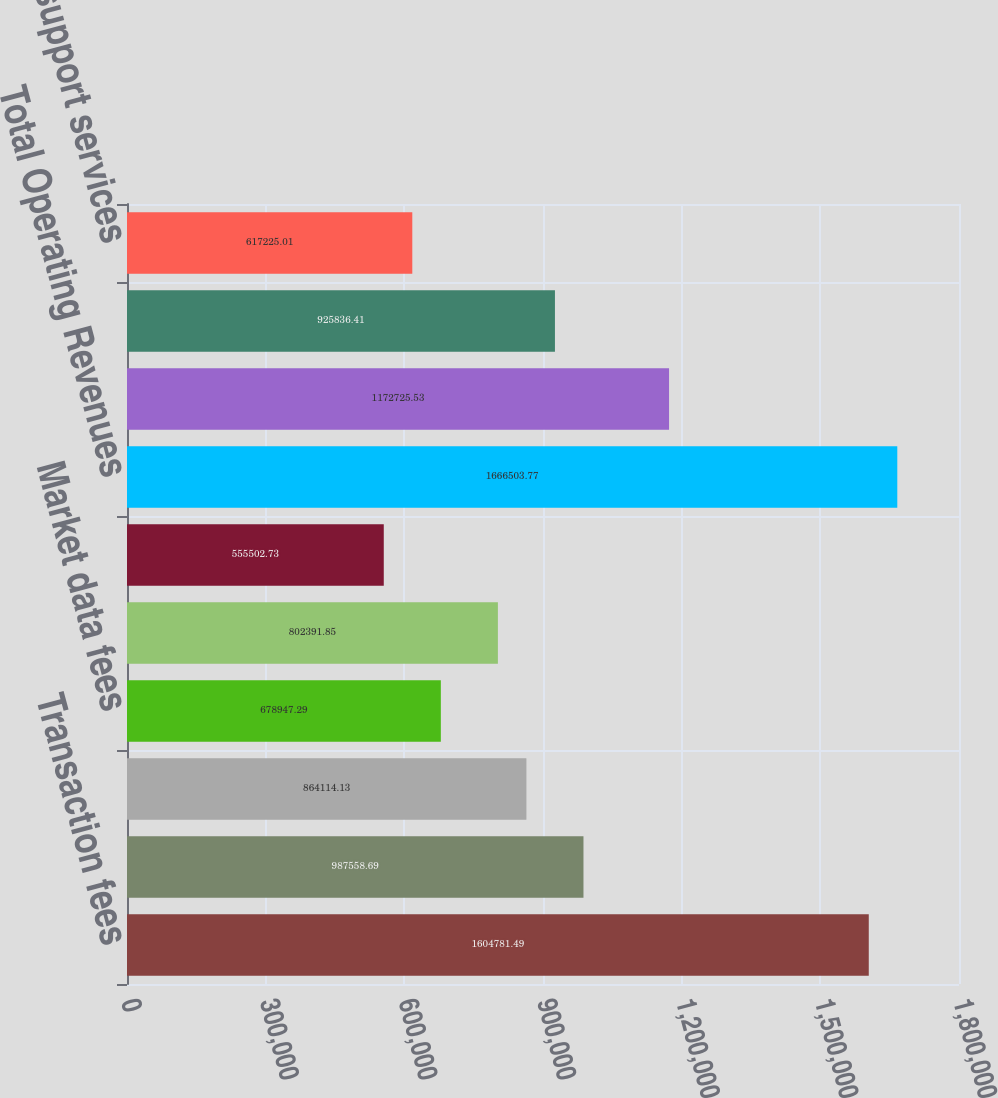Convert chart. <chart><loc_0><loc_0><loc_500><loc_500><bar_chart><fcel>Transaction fees<fcel>Access fees<fcel>Exchange services and other<fcel>Market data fees<fcel>Regulatory fees<fcel>Other revenue<fcel>Total Operating Revenues<fcel>Compensation and benefits<fcel>Depreciation and amortization<fcel>Technology support services<nl><fcel>1.60478e+06<fcel>987559<fcel>864114<fcel>678947<fcel>802392<fcel>555503<fcel>1.6665e+06<fcel>1.17273e+06<fcel>925836<fcel>617225<nl></chart> 